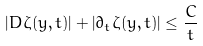Convert formula to latex. <formula><loc_0><loc_0><loc_500><loc_500>\left | { D } \zeta ( y , t ) \right | + \left | \partial _ { t } \zeta ( y , t ) \right | \leq \frac { C } { t }</formula> 